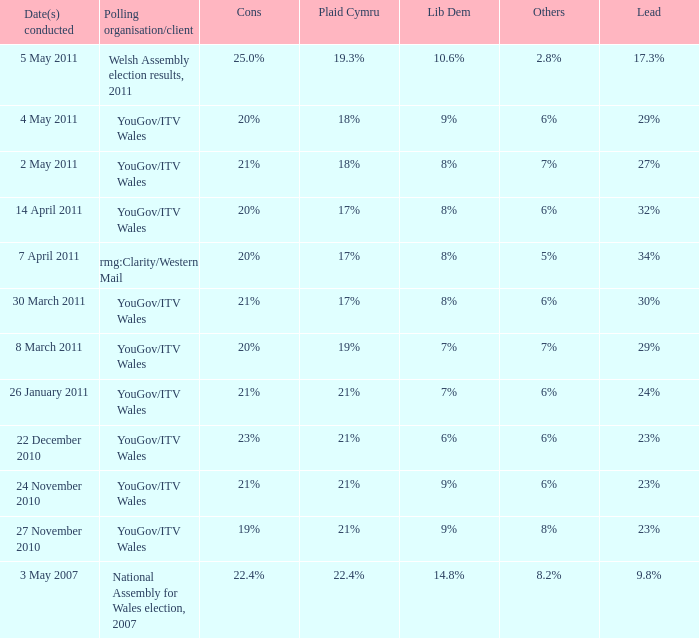I'm looking to parse the entire table for insights. Could you assist me with that? {'header': ['Date(s) conducted', 'Polling organisation/client', 'Cons', 'Plaid Cymru', 'Lib Dem', 'Others', 'Lead'], 'rows': [['5 May 2011', 'Welsh Assembly election results, 2011', '25.0%', '19.3%', '10.6%', '2.8%', '17.3%'], ['4 May 2011', 'YouGov/ITV Wales', '20%', '18%', '9%', '6%', '29%'], ['2 May 2011', 'YouGov/ITV Wales', '21%', '18%', '8%', '7%', '27%'], ['14 April 2011', 'YouGov/ITV Wales', '20%', '17%', '8%', '6%', '32%'], ['7 April 2011', 'rmg:Clarity/Western Mail', '20%', '17%', '8%', '5%', '34%'], ['30 March 2011', 'YouGov/ITV Wales', '21%', '17%', '8%', '6%', '30%'], ['8 March 2011', 'YouGov/ITV Wales', '20%', '19%', '7%', '7%', '29%'], ['26 January 2011', 'YouGov/ITV Wales', '21%', '21%', '7%', '6%', '24%'], ['22 December 2010', 'YouGov/ITV Wales', '23%', '21%', '6%', '6%', '23%'], ['24 November 2010', 'YouGov/ITV Wales', '21%', '21%', '9%', '6%', '23%'], ['27 November 2010', 'YouGov/ITV Wales', '19%', '21%', '9%', '8%', '23%'], ['3 May 2007', 'National Assembly for Wales election, 2007', '22.4%', '22.4%', '14.8%', '8.2%', '9.8%']]} What are the dates when plaid cymru achieved 19% in polls? 8 March 2011. 